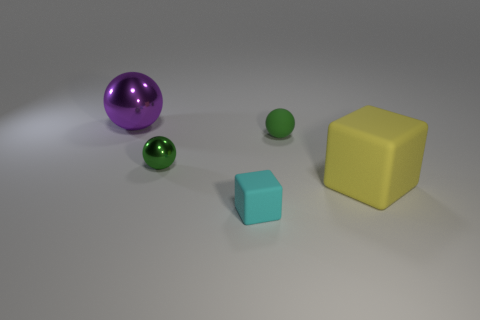Add 3 small cyan rubber spheres. How many objects exist? 8 Subtract all blocks. How many objects are left? 3 Add 4 big cyan blocks. How many big cyan blocks exist? 4 Subtract 1 purple spheres. How many objects are left? 4 Subtract all cyan metal spheres. Subtract all purple spheres. How many objects are left? 4 Add 2 large metal spheres. How many large metal spheres are left? 3 